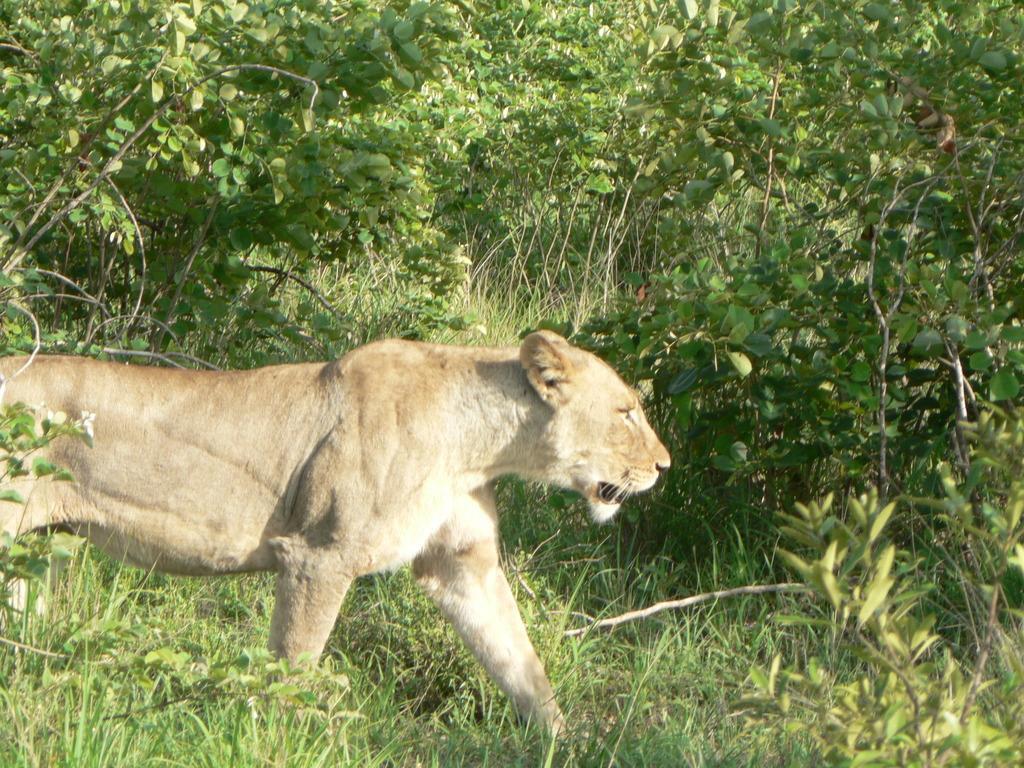Please provide a concise description of this image. In this image, there is green grass on the ground, there are some green color plants, at the left side we can see a tiger. 